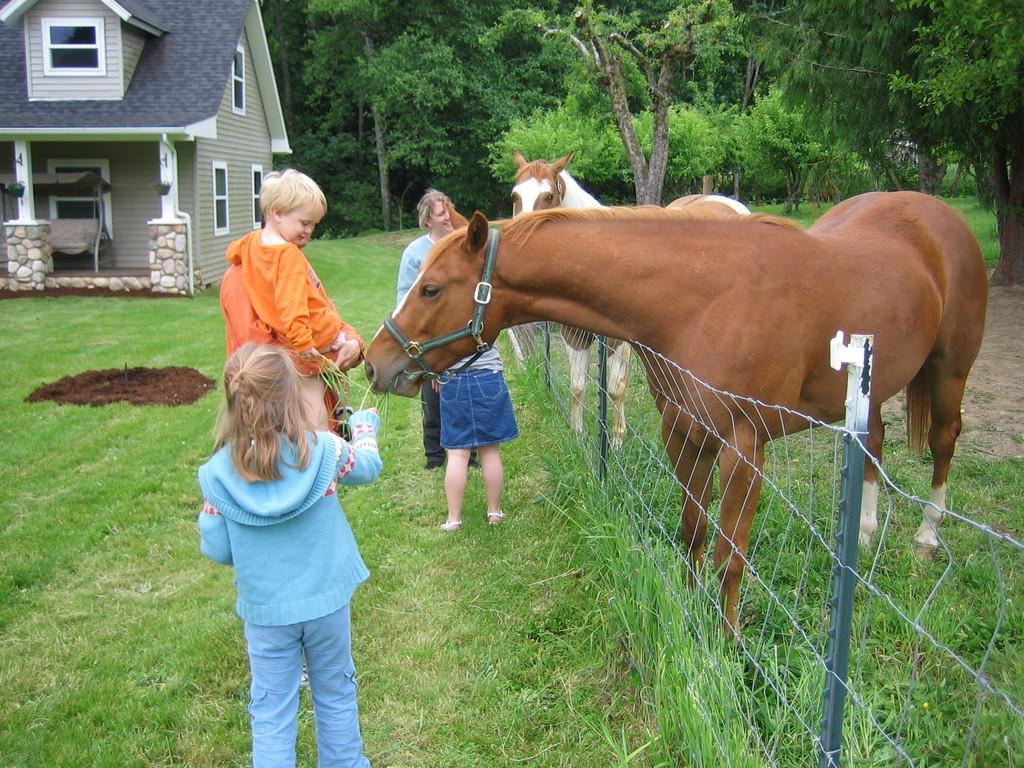Can you describe this image briefly? In this image, we can see two horses are near to the wire fencing. Here a horse is eating grass. In the middle of the image, we can see few people. Here a person is carrying a child. At the bottom, we can see grass, few plants. Background there are so many trees , house, wall, pillars, windows and swing bench. 